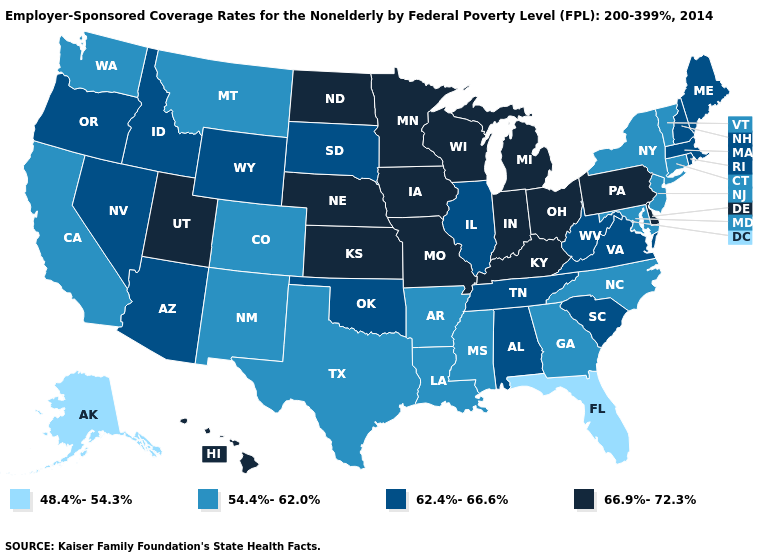Which states have the lowest value in the USA?
Give a very brief answer. Alaska, Florida. Name the states that have a value in the range 62.4%-66.6%?
Concise answer only. Alabama, Arizona, Idaho, Illinois, Maine, Massachusetts, Nevada, New Hampshire, Oklahoma, Oregon, Rhode Island, South Carolina, South Dakota, Tennessee, Virginia, West Virginia, Wyoming. Does Vermont have a higher value than Alaska?
Give a very brief answer. Yes. Name the states that have a value in the range 54.4%-62.0%?
Give a very brief answer. Arkansas, California, Colorado, Connecticut, Georgia, Louisiana, Maryland, Mississippi, Montana, New Jersey, New Mexico, New York, North Carolina, Texas, Vermont, Washington. Does New Mexico have the lowest value in the USA?
Write a very short answer. No. Does Pennsylvania have the same value as Ohio?
Keep it brief. Yes. Name the states that have a value in the range 62.4%-66.6%?
Concise answer only. Alabama, Arizona, Idaho, Illinois, Maine, Massachusetts, Nevada, New Hampshire, Oklahoma, Oregon, Rhode Island, South Carolina, South Dakota, Tennessee, Virginia, West Virginia, Wyoming. Name the states that have a value in the range 62.4%-66.6%?
Be succinct. Alabama, Arizona, Idaho, Illinois, Maine, Massachusetts, Nevada, New Hampshire, Oklahoma, Oregon, Rhode Island, South Carolina, South Dakota, Tennessee, Virginia, West Virginia, Wyoming. Name the states that have a value in the range 66.9%-72.3%?
Answer briefly. Delaware, Hawaii, Indiana, Iowa, Kansas, Kentucky, Michigan, Minnesota, Missouri, Nebraska, North Dakota, Ohio, Pennsylvania, Utah, Wisconsin. What is the value of Georgia?
Quick response, please. 54.4%-62.0%. Does Kansas have the highest value in the USA?
Quick response, please. Yes. Name the states that have a value in the range 62.4%-66.6%?
Short answer required. Alabama, Arizona, Idaho, Illinois, Maine, Massachusetts, Nevada, New Hampshire, Oklahoma, Oregon, Rhode Island, South Carolina, South Dakota, Tennessee, Virginia, West Virginia, Wyoming. Does South Carolina have the highest value in the South?
Be succinct. No. What is the value of New York?
Quick response, please. 54.4%-62.0%. Name the states that have a value in the range 54.4%-62.0%?
Give a very brief answer. Arkansas, California, Colorado, Connecticut, Georgia, Louisiana, Maryland, Mississippi, Montana, New Jersey, New Mexico, New York, North Carolina, Texas, Vermont, Washington. 